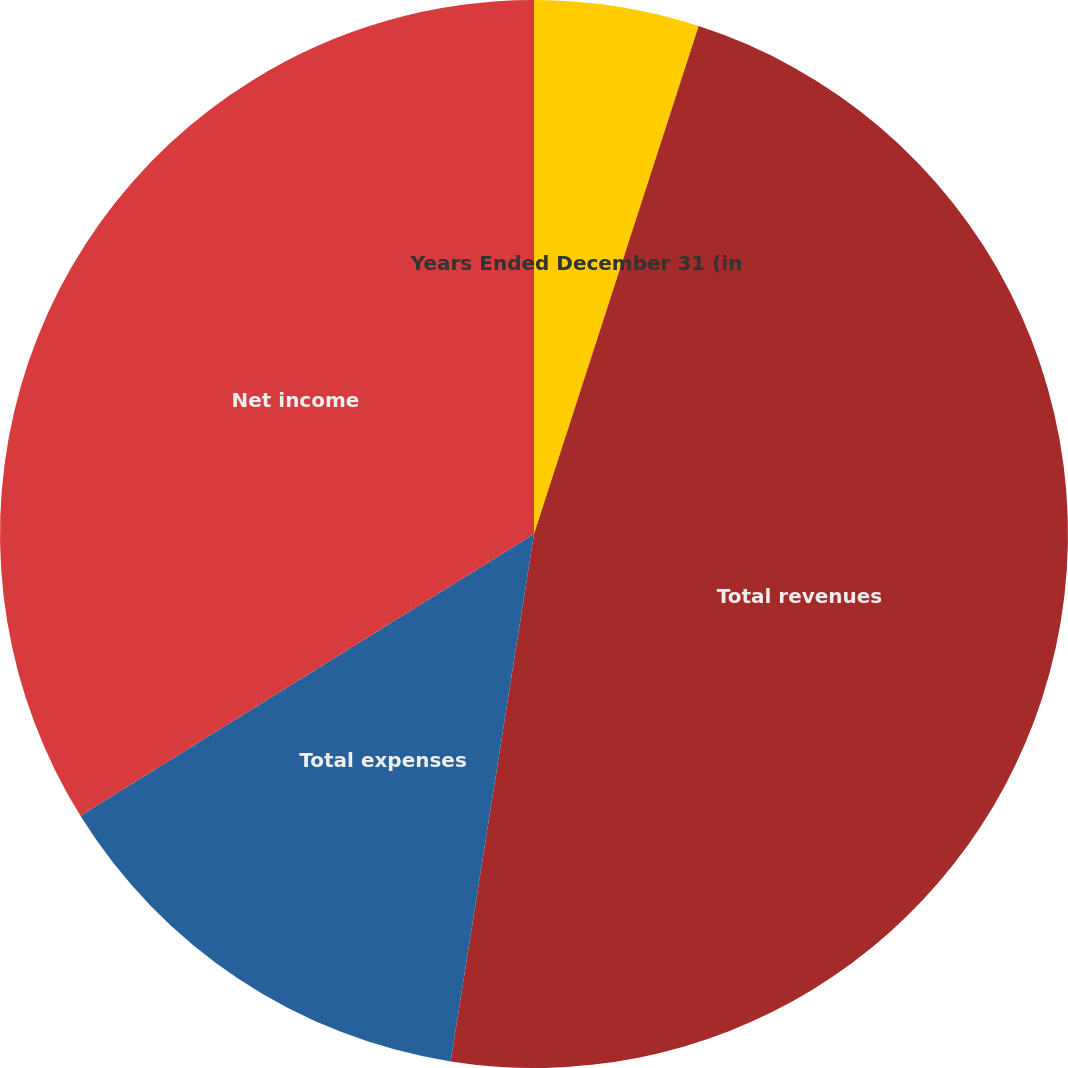<chart> <loc_0><loc_0><loc_500><loc_500><pie_chart><fcel>Years Ended December 31 (in<fcel>Total revenues<fcel>Total expenses<fcel>Net income<nl><fcel>4.99%<fcel>47.51%<fcel>13.66%<fcel>33.85%<nl></chart> 